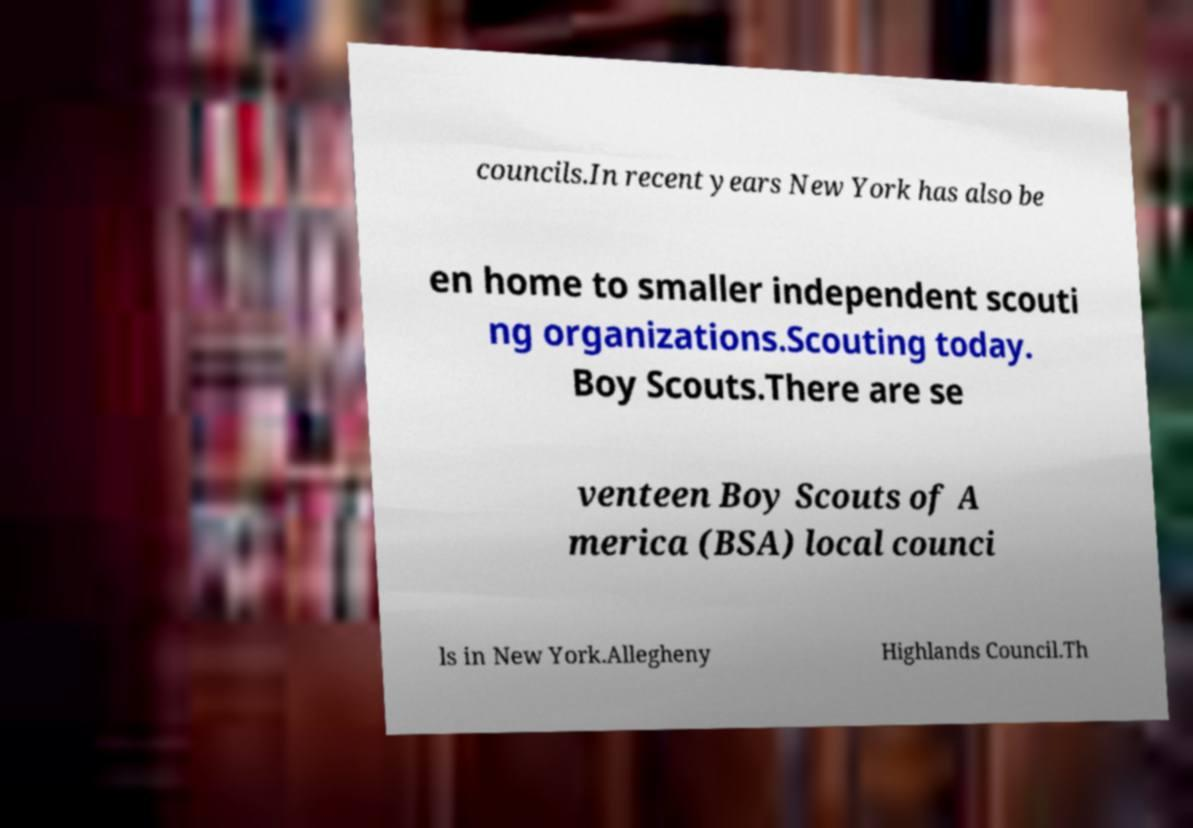Could you extract and type out the text from this image? councils.In recent years New York has also be en home to smaller independent scouti ng organizations.Scouting today. Boy Scouts.There are se venteen Boy Scouts of A merica (BSA) local counci ls in New York.Allegheny Highlands Council.Th 